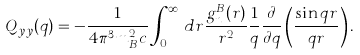Convert formula to latex. <formula><loc_0><loc_0><loc_500><loc_500>Q _ { y y } ( q ) = - \frac { 1 } { 4 \pi ^ { 3 } m _ { B } ^ { 2 } c } \int _ { 0 } ^ { \infty } \, d r \frac { g ^ { B } _ { n } ( r ) } { r ^ { 2 } } \frac { 1 } { q } \frac { \partial } { \partial q } \left ( \frac { \sin q r } { q r } \right ) .</formula> 